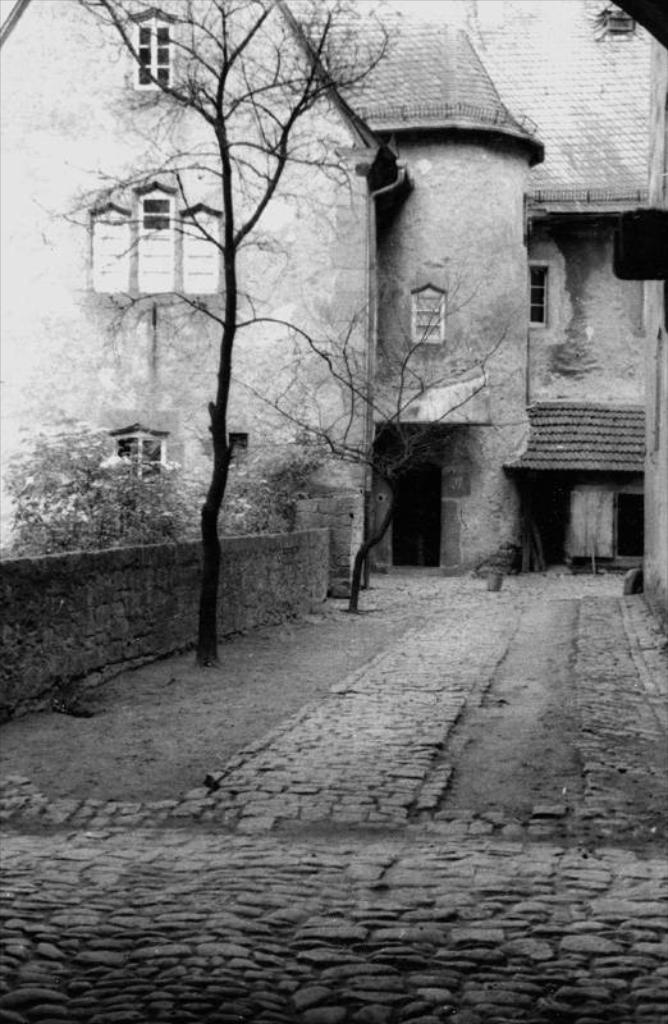What is the color scheme of the image? The image is black and white. What structure can be seen in the image? There is a building in the image. What type of vegetation is present in the image? There are trees in front of the building in the image. How many beds can be seen in the image? There are no beds present in the image. What type of chicken is depicted in the image? There is no chicken present in the image. 